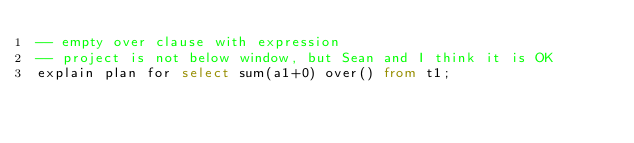<code> <loc_0><loc_0><loc_500><loc_500><_SQL_>-- empty over clause with expression
-- project is not below window, but Sean and I think it is OK
explain plan for select sum(a1+0) over() from t1;
</code> 